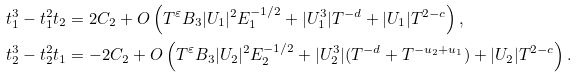<formula> <loc_0><loc_0><loc_500><loc_500>& t _ { 1 } ^ { 3 } - t _ { 1 } ^ { 2 } t _ { 2 } = 2 C _ { 2 } + O \left ( T ^ { \varepsilon } B _ { 3 } | U _ { 1 } | ^ { 2 } E _ { 1 } ^ { - 1 / 2 } + | U _ { 1 } ^ { 3 } | T ^ { - d } + | U _ { 1 } | T ^ { 2 - c } \right ) , \\ & t _ { 2 } ^ { 3 } - t _ { 2 } ^ { 2 } t _ { 1 } = - 2 C _ { 2 } + O \left ( T ^ { \varepsilon } B _ { 3 } | U _ { 2 } | ^ { 2 } E _ { 2 } ^ { - 1 / 2 } + | U _ { 2 } ^ { 3 } | ( T ^ { - d } + T ^ { - u _ { 2 } + u _ { 1 } } ) + | U _ { 2 } | T ^ { 2 - c } \right ) .</formula> 